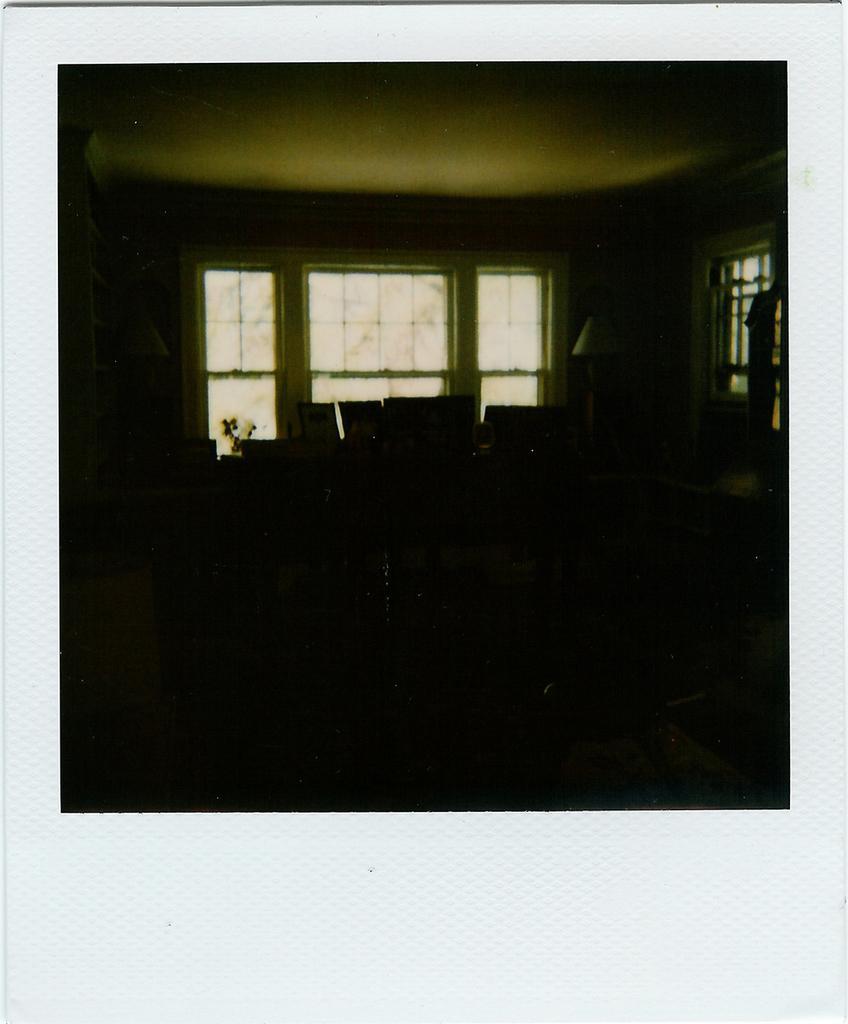Describe this image in one or two sentences. In this picture I can see inside of the building, full of dark and borders to the image. 